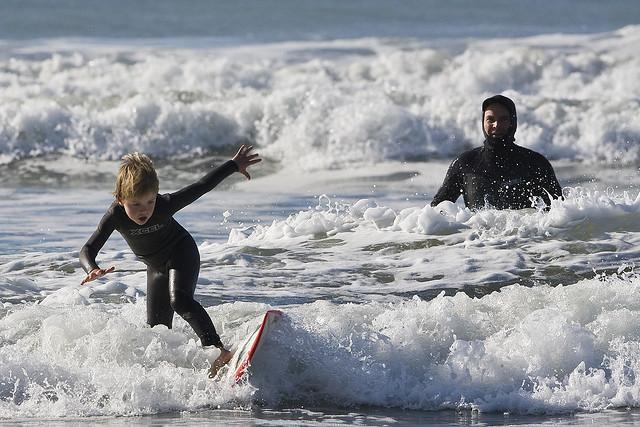Why are they wearing wetsuits?

Choices:
A) for fun
B) cold water
C) easier finding
D) showing off cold water 